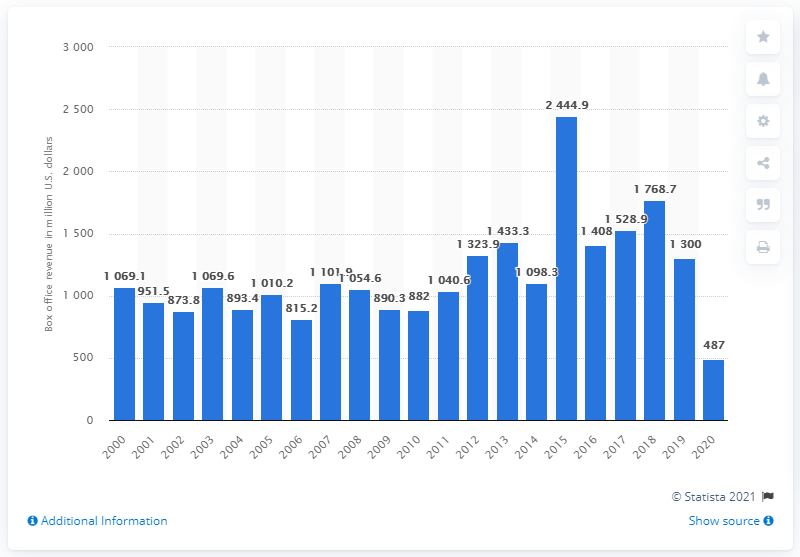Draw attention to some important aspects in this diagram. Universal's domestic box office revenue in 2020 was $487 million. 